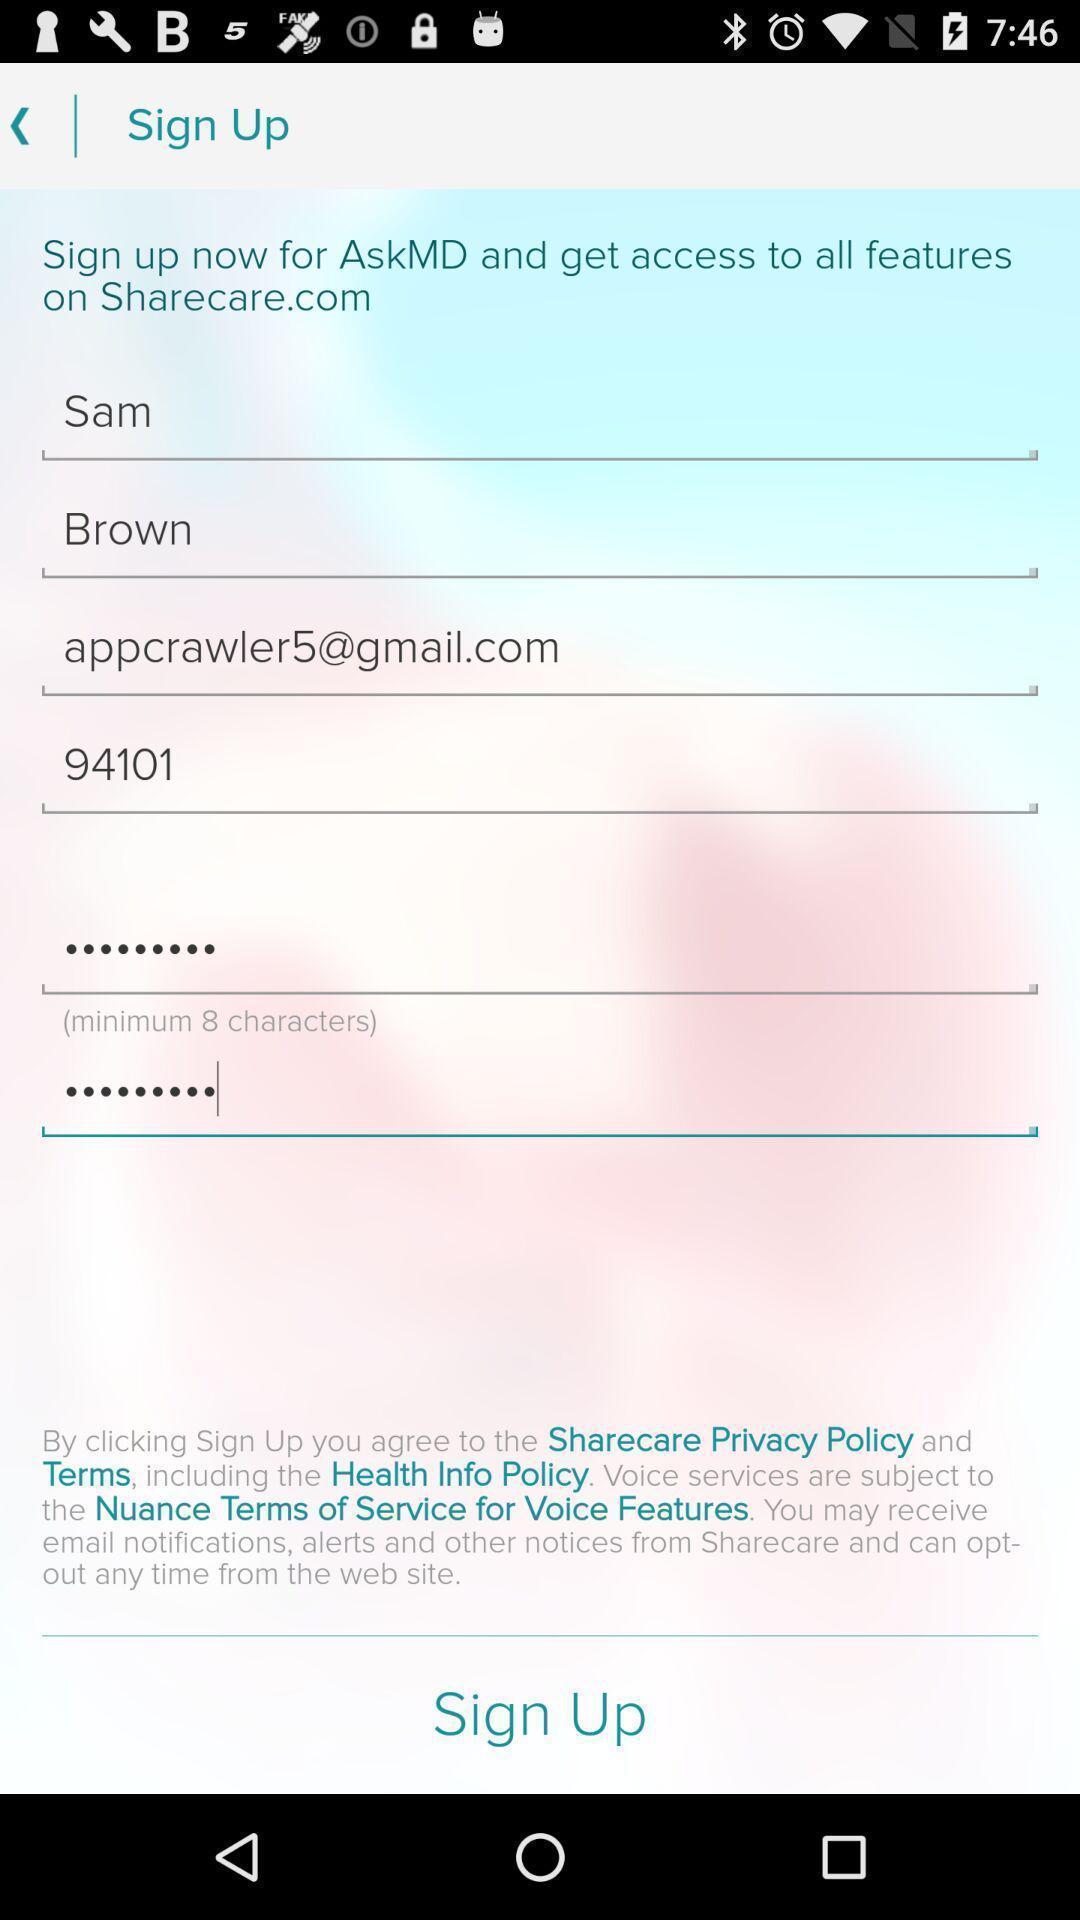Summarize the information in this screenshot. Sign up page with different options. 